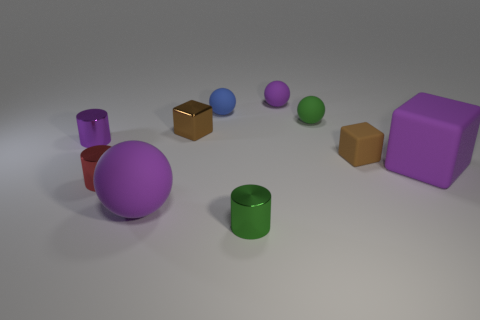What number of metal objects are small green things or tiny red cylinders?
Provide a succinct answer. 2. What color is the matte sphere that is left of the small brown metal object?
Provide a succinct answer. Purple. There is a red shiny object that is the same size as the brown metallic thing; what is its shape?
Your answer should be very brief. Cylinder. There is a large rubber ball; is it the same color as the cylinder behind the red shiny object?
Make the answer very short. Yes. What number of things are tiny rubber objects in front of the purple metallic thing or green objects behind the small purple shiny cylinder?
Ensure brevity in your answer.  2. What material is the purple cylinder that is the same size as the red cylinder?
Provide a short and direct response. Metal. What number of other objects are there of the same material as the big block?
Provide a short and direct response. 5. Is the shape of the small green object in front of the large rubber block the same as the small purple object that is in front of the tiny purple rubber ball?
Your answer should be very brief. Yes. There is a rubber sphere that is in front of the shiny cube left of the tiny matte object that is in front of the small purple cylinder; what is its color?
Ensure brevity in your answer.  Purple. How many other things are there of the same color as the metallic block?
Offer a terse response. 1. 